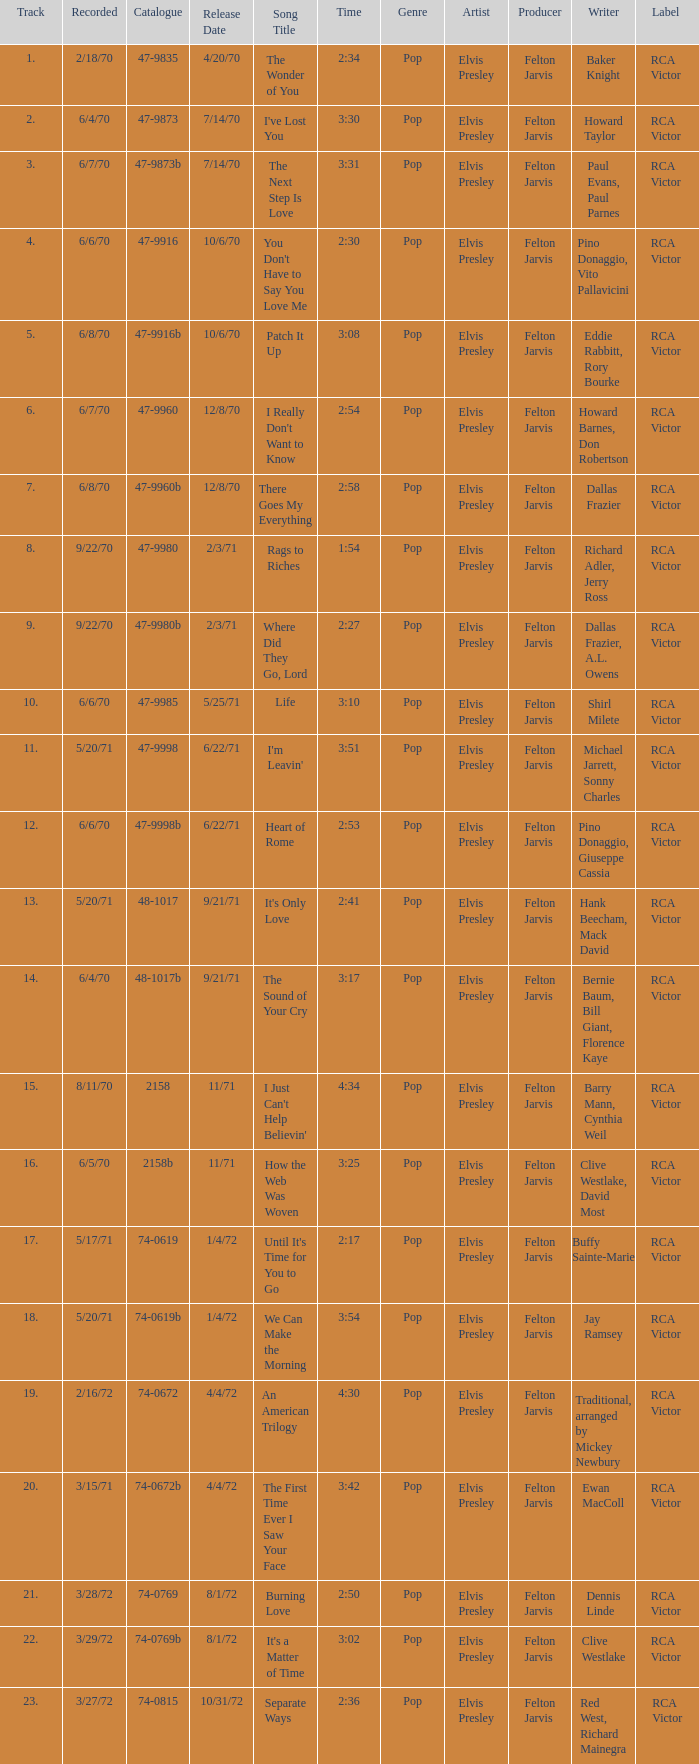Which song was released 12/8/70 with a time of 2:54? I Really Don't Want to Know. 